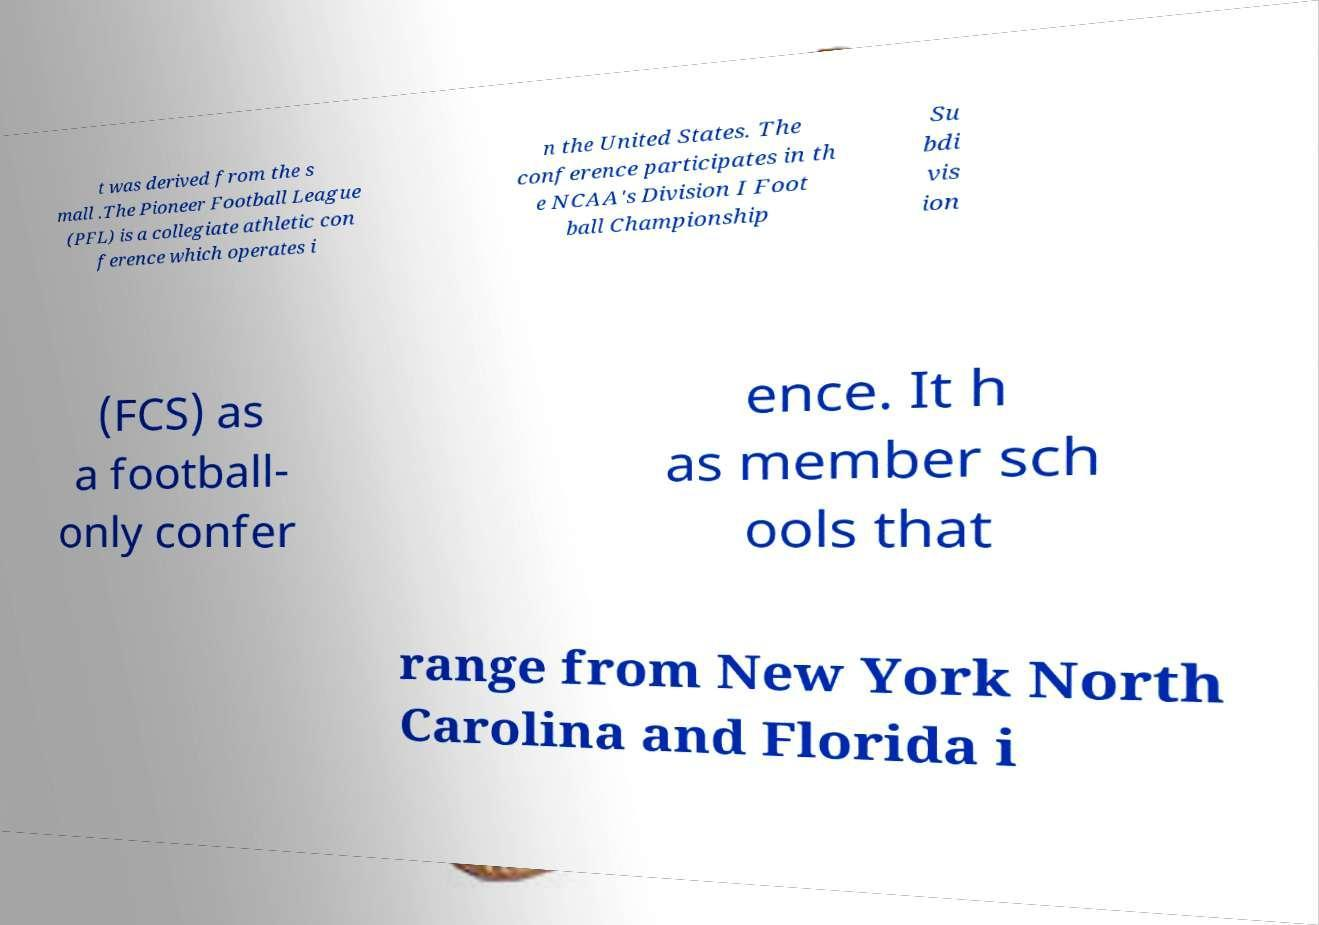I need the written content from this picture converted into text. Can you do that? t was derived from the s mall .The Pioneer Football League (PFL) is a collegiate athletic con ference which operates i n the United States. The conference participates in th e NCAA's Division I Foot ball Championship Su bdi vis ion (FCS) as a football- only confer ence. It h as member sch ools that range from New York North Carolina and Florida i 